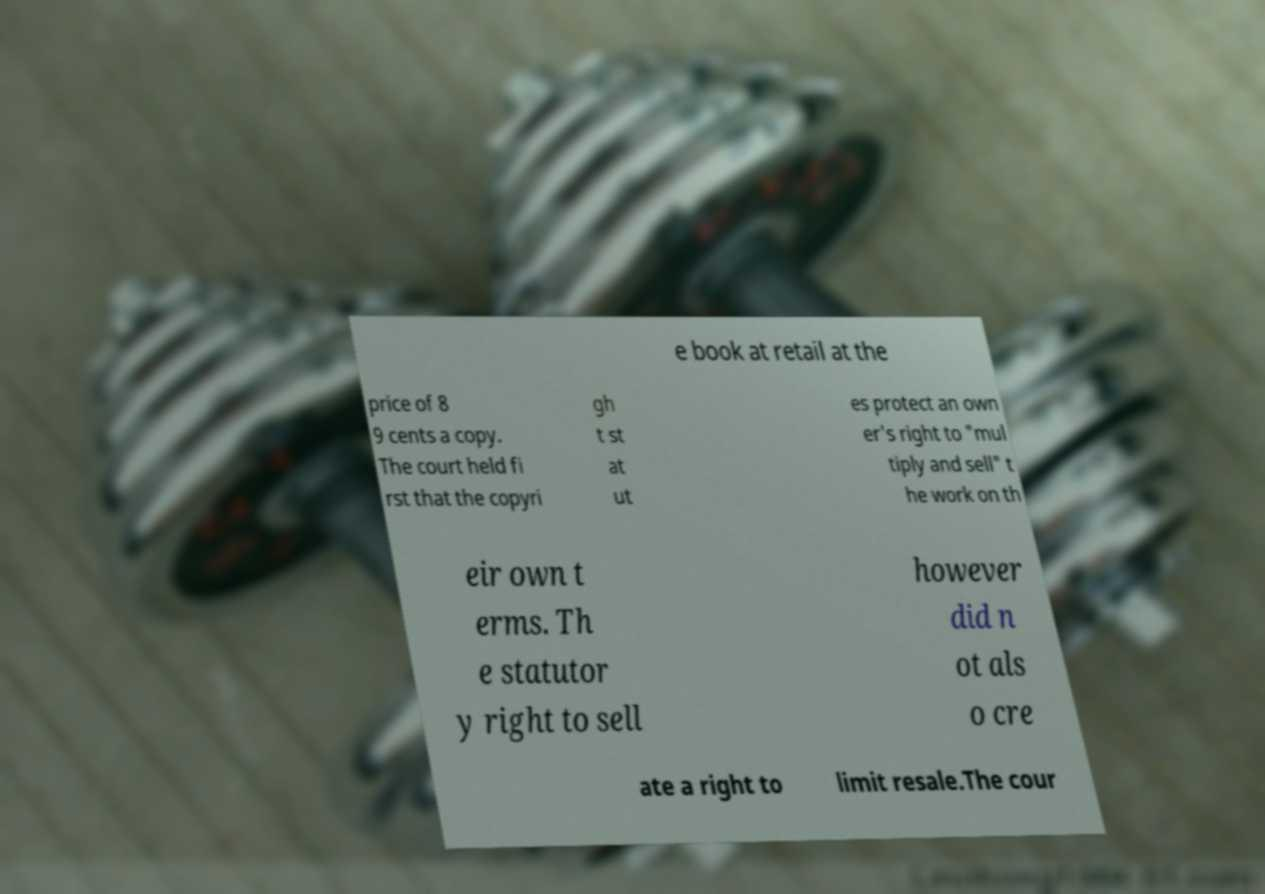Could you extract and type out the text from this image? e book at retail at the price of 8 9 cents a copy. The court held fi rst that the copyri gh t st at ut es protect an own er's right to "mul tiply and sell" t he work on th eir own t erms. Th e statutor y right to sell however did n ot als o cre ate a right to limit resale.The cour 